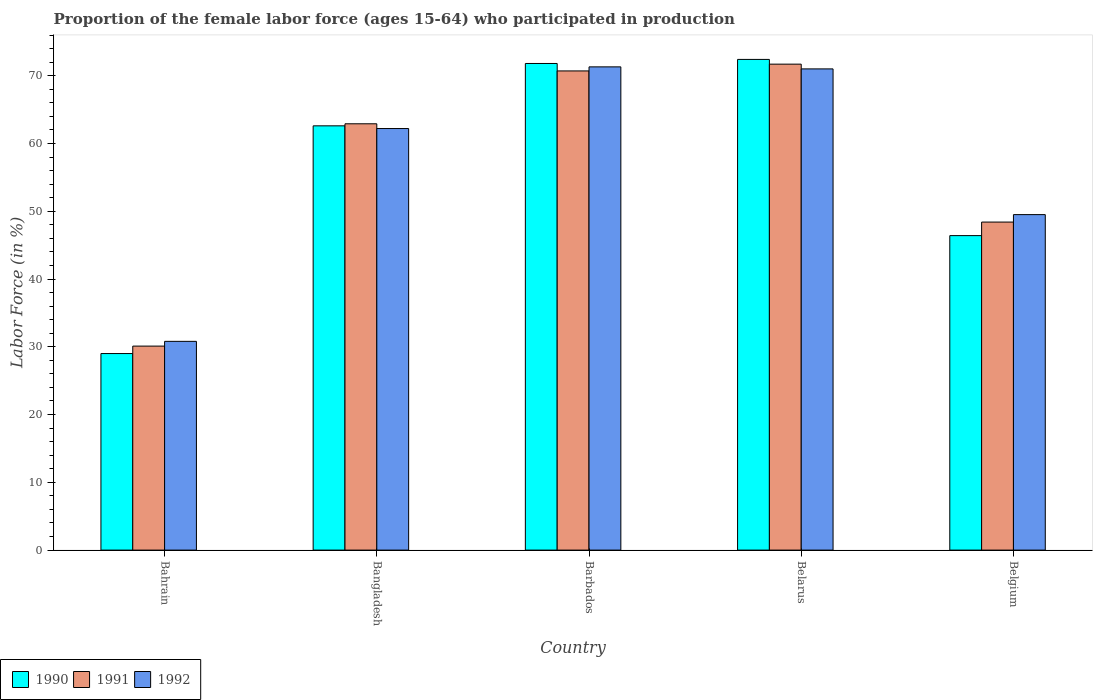How many different coloured bars are there?
Your answer should be very brief. 3. Are the number of bars per tick equal to the number of legend labels?
Offer a terse response. Yes. Are the number of bars on each tick of the X-axis equal?
Your response must be concise. Yes. How many bars are there on the 1st tick from the left?
Offer a very short reply. 3. What is the label of the 3rd group of bars from the left?
Your answer should be very brief. Barbados. In how many cases, is the number of bars for a given country not equal to the number of legend labels?
Ensure brevity in your answer.  0. What is the proportion of the female labor force who participated in production in 1992 in Belgium?
Give a very brief answer. 49.5. Across all countries, what is the maximum proportion of the female labor force who participated in production in 1991?
Provide a succinct answer. 71.7. Across all countries, what is the minimum proportion of the female labor force who participated in production in 1990?
Your answer should be very brief. 29. In which country was the proportion of the female labor force who participated in production in 1991 maximum?
Make the answer very short. Belarus. In which country was the proportion of the female labor force who participated in production in 1990 minimum?
Your response must be concise. Bahrain. What is the total proportion of the female labor force who participated in production in 1992 in the graph?
Your answer should be very brief. 284.8. What is the difference between the proportion of the female labor force who participated in production in 1991 in Bahrain and that in Belarus?
Your answer should be very brief. -41.6. What is the difference between the proportion of the female labor force who participated in production in 1990 in Belgium and the proportion of the female labor force who participated in production in 1991 in Bahrain?
Give a very brief answer. 16.3. What is the average proportion of the female labor force who participated in production in 1992 per country?
Your response must be concise. 56.96. What is the difference between the proportion of the female labor force who participated in production of/in 1990 and proportion of the female labor force who participated in production of/in 1992 in Belarus?
Provide a succinct answer. 1.4. What is the ratio of the proportion of the female labor force who participated in production in 1991 in Bangladesh to that in Belarus?
Your response must be concise. 0.88. What is the difference between the highest and the second highest proportion of the female labor force who participated in production in 1991?
Give a very brief answer. -7.8. What is the difference between the highest and the lowest proportion of the female labor force who participated in production in 1991?
Provide a succinct answer. 41.6. Is the sum of the proportion of the female labor force who participated in production in 1990 in Barbados and Belarus greater than the maximum proportion of the female labor force who participated in production in 1992 across all countries?
Your answer should be very brief. Yes. What does the 3rd bar from the left in Belgium represents?
Ensure brevity in your answer.  1992. Is it the case that in every country, the sum of the proportion of the female labor force who participated in production in 1990 and proportion of the female labor force who participated in production in 1992 is greater than the proportion of the female labor force who participated in production in 1991?
Offer a very short reply. Yes. Are all the bars in the graph horizontal?
Provide a short and direct response. No. How many countries are there in the graph?
Your answer should be very brief. 5. Does the graph contain any zero values?
Keep it short and to the point. No. Where does the legend appear in the graph?
Offer a very short reply. Bottom left. How many legend labels are there?
Provide a short and direct response. 3. How are the legend labels stacked?
Your answer should be compact. Horizontal. What is the title of the graph?
Your response must be concise. Proportion of the female labor force (ages 15-64) who participated in production. Does "2001" appear as one of the legend labels in the graph?
Offer a very short reply. No. What is the label or title of the X-axis?
Your answer should be very brief. Country. What is the Labor Force (in %) of 1991 in Bahrain?
Provide a short and direct response. 30.1. What is the Labor Force (in %) of 1992 in Bahrain?
Your answer should be compact. 30.8. What is the Labor Force (in %) of 1990 in Bangladesh?
Your response must be concise. 62.6. What is the Labor Force (in %) in 1991 in Bangladesh?
Give a very brief answer. 62.9. What is the Labor Force (in %) in 1992 in Bangladesh?
Offer a terse response. 62.2. What is the Labor Force (in %) of 1990 in Barbados?
Your answer should be compact. 71.8. What is the Labor Force (in %) of 1991 in Barbados?
Give a very brief answer. 70.7. What is the Labor Force (in %) of 1992 in Barbados?
Provide a short and direct response. 71.3. What is the Labor Force (in %) in 1990 in Belarus?
Your response must be concise. 72.4. What is the Labor Force (in %) of 1991 in Belarus?
Keep it short and to the point. 71.7. What is the Labor Force (in %) in 1990 in Belgium?
Keep it short and to the point. 46.4. What is the Labor Force (in %) of 1991 in Belgium?
Give a very brief answer. 48.4. What is the Labor Force (in %) of 1992 in Belgium?
Make the answer very short. 49.5. Across all countries, what is the maximum Labor Force (in %) in 1990?
Your answer should be compact. 72.4. Across all countries, what is the maximum Labor Force (in %) of 1991?
Provide a short and direct response. 71.7. Across all countries, what is the maximum Labor Force (in %) of 1992?
Provide a succinct answer. 71.3. Across all countries, what is the minimum Labor Force (in %) of 1991?
Your answer should be compact. 30.1. Across all countries, what is the minimum Labor Force (in %) of 1992?
Provide a succinct answer. 30.8. What is the total Labor Force (in %) in 1990 in the graph?
Provide a short and direct response. 282.2. What is the total Labor Force (in %) of 1991 in the graph?
Your answer should be compact. 283.8. What is the total Labor Force (in %) in 1992 in the graph?
Provide a succinct answer. 284.8. What is the difference between the Labor Force (in %) in 1990 in Bahrain and that in Bangladesh?
Provide a succinct answer. -33.6. What is the difference between the Labor Force (in %) in 1991 in Bahrain and that in Bangladesh?
Your response must be concise. -32.8. What is the difference between the Labor Force (in %) of 1992 in Bahrain and that in Bangladesh?
Ensure brevity in your answer.  -31.4. What is the difference between the Labor Force (in %) in 1990 in Bahrain and that in Barbados?
Give a very brief answer. -42.8. What is the difference between the Labor Force (in %) in 1991 in Bahrain and that in Barbados?
Your answer should be compact. -40.6. What is the difference between the Labor Force (in %) in 1992 in Bahrain and that in Barbados?
Ensure brevity in your answer.  -40.5. What is the difference between the Labor Force (in %) in 1990 in Bahrain and that in Belarus?
Make the answer very short. -43.4. What is the difference between the Labor Force (in %) of 1991 in Bahrain and that in Belarus?
Give a very brief answer. -41.6. What is the difference between the Labor Force (in %) of 1992 in Bahrain and that in Belarus?
Offer a terse response. -40.2. What is the difference between the Labor Force (in %) of 1990 in Bahrain and that in Belgium?
Make the answer very short. -17.4. What is the difference between the Labor Force (in %) of 1991 in Bahrain and that in Belgium?
Offer a terse response. -18.3. What is the difference between the Labor Force (in %) in 1992 in Bahrain and that in Belgium?
Your answer should be very brief. -18.7. What is the difference between the Labor Force (in %) of 1990 in Bangladesh and that in Belarus?
Give a very brief answer. -9.8. What is the difference between the Labor Force (in %) in 1990 in Bangladesh and that in Belgium?
Offer a terse response. 16.2. What is the difference between the Labor Force (in %) of 1992 in Barbados and that in Belarus?
Offer a terse response. 0.3. What is the difference between the Labor Force (in %) in 1990 in Barbados and that in Belgium?
Offer a terse response. 25.4. What is the difference between the Labor Force (in %) in 1991 in Barbados and that in Belgium?
Keep it short and to the point. 22.3. What is the difference between the Labor Force (in %) in 1992 in Barbados and that in Belgium?
Give a very brief answer. 21.8. What is the difference between the Labor Force (in %) of 1990 in Belarus and that in Belgium?
Offer a very short reply. 26. What is the difference between the Labor Force (in %) of 1991 in Belarus and that in Belgium?
Keep it short and to the point. 23.3. What is the difference between the Labor Force (in %) in 1990 in Bahrain and the Labor Force (in %) in 1991 in Bangladesh?
Give a very brief answer. -33.9. What is the difference between the Labor Force (in %) in 1990 in Bahrain and the Labor Force (in %) in 1992 in Bangladesh?
Ensure brevity in your answer.  -33.2. What is the difference between the Labor Force (in %) in 1991 in Bahrain and the Labor Force (in %) in 1992 in Bangladesh?
Offer a very short reply. -32.1. What is the difference between the Labor Force (in %) in 1990 in Bahrain and the Labor Force (in %) in 1991 in Barbados?
Give a very brief answer. -41.7. What is the difference between the Labor Force (in %) in 1990 in Bahrain and the Labor Force (in %) in 1992 in Barbados?
Provide a short and direct response. -42.3. What is the difference between the Labor Force (in %) in 1991 in Bahrain and the Labor Force (in %) in 1992 in Barbados?
Make the answer very short. -41.2. What is the difference between the Labor Force (in %) in 1990 in Bahrain and the Labor Force (in %) in 1991 in Belarus?
Your response must be concise. -42.7. What is the difference between the Labor Force (in %) in 1990 in Bahrain and the Labor Force (in %) in 1992 in Belarus?
Give a very brief answer. -42. What is the difference between the Labor Force (in %) in 1991 in Bahrain and the Labor Force (in %) in 1992 in Belarus?
Provide a short and direct response. -40.9. What is the difference between the Labor Force (in %) of 1990 in Bahrain and the Labor Force (in %) of 1991 in Belgium?
Offer a very short reply. -19.4. What is the difference between the Labor Force (in %) of 1990 in Bahrain and the Labor Force (in %) of 1992 in Belgium?
Offer a terse response. -20.5. What is the difference between the Labor Force (in %) of 1991 in Bahrain and the Labor Force (in %) of 1992 in Belgium?
Your answer should be compact. -19.4. What is the difference between the Labor Force (in %) in 1991 in Bangladesh and the Labor Force (in %) in 1992 in Barbados?
Your response must be concise. -8.4. What is the difference between the Labor Force (in %) in 1990 in Bangladesh and the Labor Force (in %) in 1991 in Belarus?
Provide a short and direct response. -9.1. What is the difference between the Labor Force (in %) in 1990 in Barbados and the Labor Force (in %) in 1991 in Belarus?
Your response must be concise. 0.1. What is the difference between the Labor Force (in %) of 1990 in Barbados and the Labor Force (in %) of 1992 in Belarus?
Offer a terse response. 0.8. What is the difference between the Labor Force (in %) in 1991 in Barbados and the Labor Force (in %) in 1992 in Belarus?
Your answer should be compact. -0.3. What is the difference between the Labor Force (in %) of 1990 in Barbados and the Labor Force (in %) of 1991 in Belgium?
Ensure brevity in your answer.  23.4. What is the difference between the Labor Force (in %) of 1990 in Barbados and the Labor Force (in %) of 1992 in Belgium?
Your answer should be very brief. 22.3. What is the difference between the Labor Force (in %) in 1991 in Barbados and the Labor Force (in %) in 1992 in Belgium?
Offer a terse response. 21.2. What is the difference between the Labor Force (in %) in 1990 in Belarus and the Labor Force (in %) in 1992 in Belgium?
Offer a terse response. 22.9. What is the average Labor Force (in %) of 1990 per country?
Offer a terse response. 56.44. What is the average Labor Force (in %) of 1991 per country?
Your answer should be compact. 56.76. What is the average Labor Force (in %) of 1992 per country?
Your answer should be compact. 56.96. What is the difference between the Labor Force (in %) in 1990 and Labor Force (in %) in 1991 in Bahrain?
Offer a very short reply. -1.1. What is the difference between the Labor Force (in %) in 1991 and Labor Force (in %) in 1992 in Bahrain?
Your answer should be compact. -0.7. What is the difference between the Labor Force (in %) in 1990 and Labor Force (in %) in 1991 in Bangladesh?
Your response must be concise. -0.3. What is the difference between the Labor Force (in %) in 1991 and Labor Force (in %) in 1992 in Bangladesh?
Your answer should be compact. 0.7. What is the difference between the Labor Force (in %) of 1990 and Labor Force (in %) of 1991 in Barbados?
Your answer should be very brief. 1.1. What is the difference between the Labor Force (in %) in 1990 and Labor Force (in %) in 1991 in Belarus?
Keep it short and to the point. 0.7. What is the difference between the Labor Force (in %) in 1990 and Labor Force (in %) in 1991 in Belgium?
Your response must be concise. -2. What is the ratio of the Labor Force (in %) of 1990 in Bahrain to that in Bangladesh?
Offer a very short reply. 0.46. What is the ratio of the Labor Force (in %) of 1991 in Bahrain to that in Bangladesh?
Your answer should be compact. 0.48. What is the ratio of the Labor Force (in %) in 1992 in Bahrain to that in Bangladesh?
Offer a very short reply. 0.5. What is the ratio of the Labor Force (in %) of 1990 in Bahrain to that in Barbados?
Your answer should be compact. 0.4. What is the ratio of the Labor Force (in %) in 1991 in Bahrain to that in Barbados?
Your answer should be compact. 0.43. What is the ratio of the Labor Force (in %) of 1992 in Bahrain to that in Barbados?
Provide a short and direct response. 0.43. What is the ratio of the Labor Force (in %) in 1990 in Bahrain to that in Belarus?
Ensure brevity in your answer.  0.4. What is the ratio of the Labor Force (in %) of 1991 in Bahrain to that in Belarus?
Offer a very short reply. 0.42. What is the ratio of the Labor Force (in %) in 1992 in Bahrain to that in Belarus?
Your answer should be very brief. 0.43. What is the ratio of the Labor Force (in %) in 1990 in Bahrain to that in Belgium?
Ensure brevity in your answer.  0.62. What is the ratio of the Labor Force (in %) in 1991 in Bahrain to that in Belgium?
Keep it short and to the point. 0.62. What is the ratio of the Labor Force (in %) in 1992 in Bahrain to that in Belgium?
Give a very brief answer. 0.62. What is the ratio of the Labor Force (in %) of 1990 in Bangladesh to that in Barbados?
Make the answer very short. 0.87. What is the ratio of the Labor Force (in %) in 1991 in Bangladesh to that in Barbados?
Your answer should be very brief. 0.89. What is the ratio of the Labor Force (in %) in 1992 in Bangladesh to that in Barbados?
Your answer should be very brief. 0.87. What is the ratio of the Labor Force (in %) in 1990 in Bangladesh to that in Belarus?
Ensure brevity in your answer.  0.86. What is the ratio of the Labor Force (in %) of 1991 in Bangladesh to that in Belarus?
Provide a succinct answer. 0.88. What is the ratio of the Labor Force (in %) of 1992 in Bangladesh to that in Belarus?
Offer a very short reply. 0.88. What is the ratio of the Labor Force (in %) in 1990 in Bangladesh to that in Belgium?
Make the answer very short. 1.35. What is the ratio of the Labor Force (in %) in 1991 in Bangladesh to that in Belgium?
Your response must be concise. 1.3. What is the ratio of the Labor Force (in %) in 1992 in Bangladesh to that in Belgium?
Keep it short and to the point. 1.26. What is the ratio of the Labor Force (in %) in 1990 in Barbados to that in Belarus?
Your answer should be very brief. 0.99. What is the ratio of the Labor Force (in %) of 1991 in Barbados to that in Belarus?
Your answer should be very brief. 0.99. What is the ratio of the Labor Force (in %) of 1990 in Barbados to that in Belgium?
Your answer should be very brief. 1.55. What is the ratio of the Labor Force (in %) in 1991 in Barbados to that in Belgium?
Provide a succinct answer. 1.46. What is the ratio of the Labor Force (in %) in 1992 in Barbados to that in Belgium?
Make the answer very short. 1.44. What is the ratio of the Labor Force (in %) in 1990 in Belarus to that in Belgium?
Offer a very short reply. 1.56. What is the ratio of the Labor Force (in %) of 1991 in Belarus to that in Belgium?
Keep it short and to the point. 1.48. What is the ratio of the Labor Force (in %) in 1992 in Belarus to that in Belgium?
Give a very brief answer. 1.43. What is the difference between the highest and the second highest Labor Force (in %) of 1991?
Ensure brevity in your answer.  1. What is the difference between the highest and the second highest Labor Force (in %) of 1992?
Keep it short and to the point. 0.3. What is the difference between the highest and the lowest Labor Force (in %) of 1990?
Ensure brevity in your answer.  43.4. What is the difference between the highest and the lowest Labor Force (in %) in 1991?
Ensure brevity in your answer.  41.6. What is the difference between the highest and the lowest Labor Force (in %) of 1992?
Ensure brevity in your answer.  40.5. 